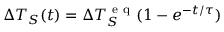<formula> <loc_0><loc_0><loc_500><loc_500>\Delta T _ { S } ( t ) = \Delta T _ { S } ^ { e q } ( 1 - e ^ { - t / \tau } )</formula> 